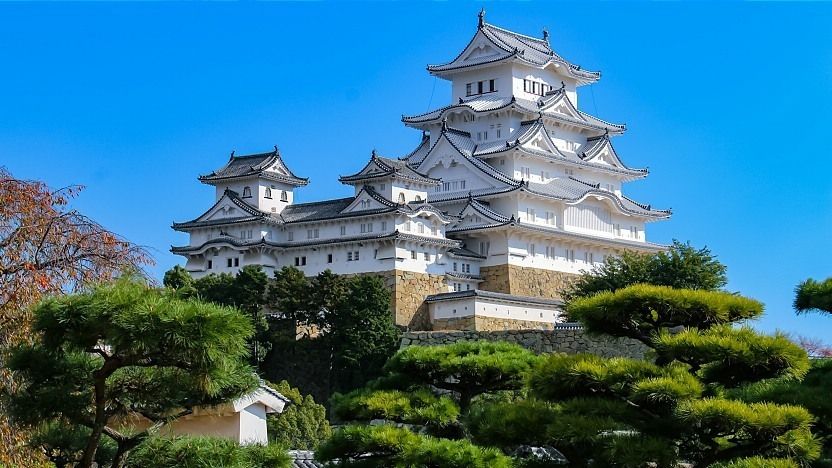Can you describe a typical day for a resident of this castle in its heyday? A typical day for a resident of Himeji Castle during its heyday would start early, just before dawn. The hustle and bustle of castle life begins with servants preparing the daily meals and the corridors filling with the soft patter of feet. Noble families would engage in daily routines of administration, strategy meetings, and training exercises in the castle grounds. sharegpt4v/samurai warriors would practice martial arts, archery, and plan defense strategies. Throughout the day, courtiers would be seen attending to their lords, managing estate affairs, and engaging in cultural activities like tea ceremonies, poetry, and music. The evenings would bring a more relaxed atmosphere, where the inhabitants would gather around for communal meals, storytelling, and discussions about the day’s events and plans for tomorrow. The castle gates would close as night fell, guards taking their positions to ensure the stronghold remained secure. 